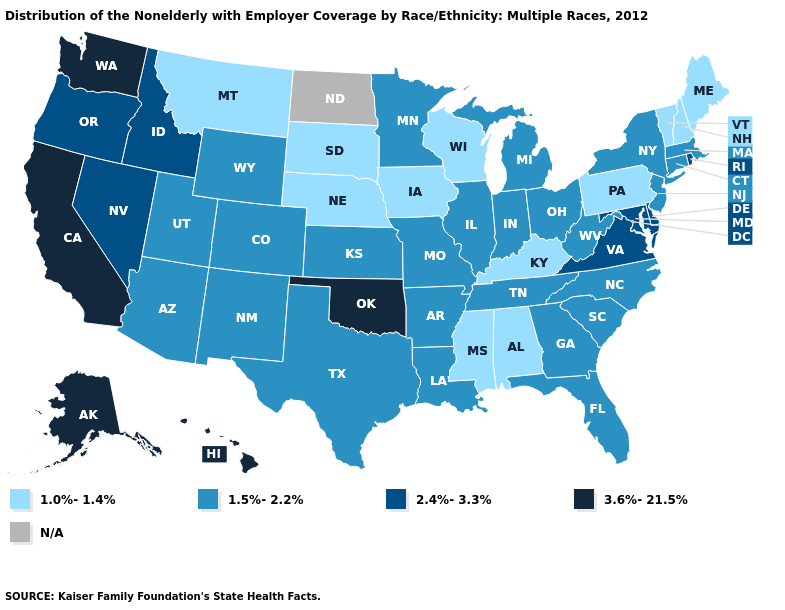How many symbols are there in the legend?
Concise answer only. 5. What is the value of Ohio?
Give a very brief answer. 1.5%-2.2%. What is the highest value in the USA?
Answer briefly. 3.6%-21.5%. Name the states that have a value in the range 2.4%-3.3%?
Write a very short answer. Delaware, Idaho, Maryland, Nevada, Oregon, Rhode Island, Virginia. Which states have the lowest value in the USA?
Quick response, please. Alabama, Iowa, Kentucky, Maine, Mississippi, Montana, Nebraska, New Hampshire, Pennsylvania, South Dakota, Vermont, Wisconsin. Does Alaska have the highest value in the USA?
Concise answer only. Yes. What is the value of Connecticut?
Keep it brief. 1.5%-2.2%. What is the value of Colorado?
Keep it brief. 1.5%-2.2%. Among the states that border Oklahoma , which have the highest value?
Answer briefly. Arkansas, Colorado, Kansas, Missouri, New Mexico, Texas. What is the lowest value in the Northeast?
Be succinct. 1.0%-1.4%. Among the states that border Michigan , does Ohio have the highest value?
Concise answer only. Yes. What is the value of Arkansas?
Be succinct. 1.5%-2.2%. What is the value of Illinois?
Short answer required. 1.5%-2.2%. Does Alaska have the highest value in the West?
Write a very short answer. Yes. 